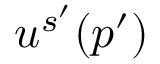Convert formula to latex. <formula><loc_0><loc_0><loc_500><loc_500>u ^ { s ^ { \prime } } ( p ^ { \prime } )</formula> 